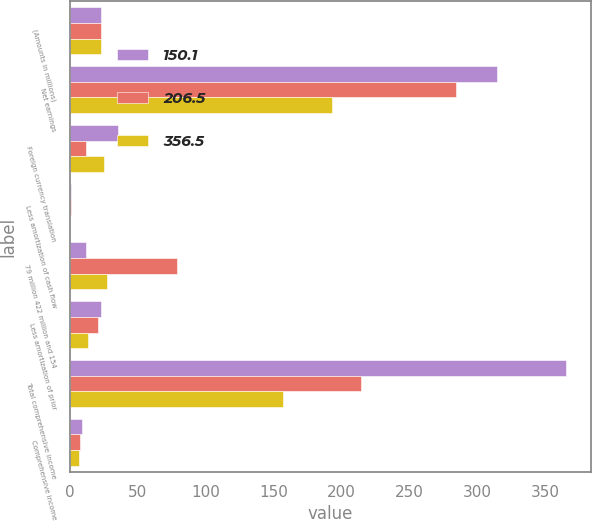<chart> <loc_0><loc_0><loc_500><loc_500><stacked_bar_chart><ecel><fcel>(Amounts in millions)<fcel>Net earnings<fcel>Foreign currency translation<fcel>Less amortization of cash flow<fcel>79 million 422 million and 154<fcel>Less amortization of prior<fcel>Total comprehensive income<fcel>Comprehensive income<nl><fcel>150.1<fcel>22.7<fcel>314.6<fcel>35<fcel>0.4<fcel>12<fcel>22.7<fcel>365<fcel>8.5<nl><fcel>206.5<fcel>22.7<fcel>283.8<fcel>11.5<fcel>0.4<fcel>78.8<fcel>20.9<fcel>214<fcel>7.5<nl><fcel>356.5<fcel>22.7<fcel>193<fcel>24.7<fcel>0.1<fcel>27.3<fcel>12.9<fcel>156.6<fcel>6.8<nl></chart> 